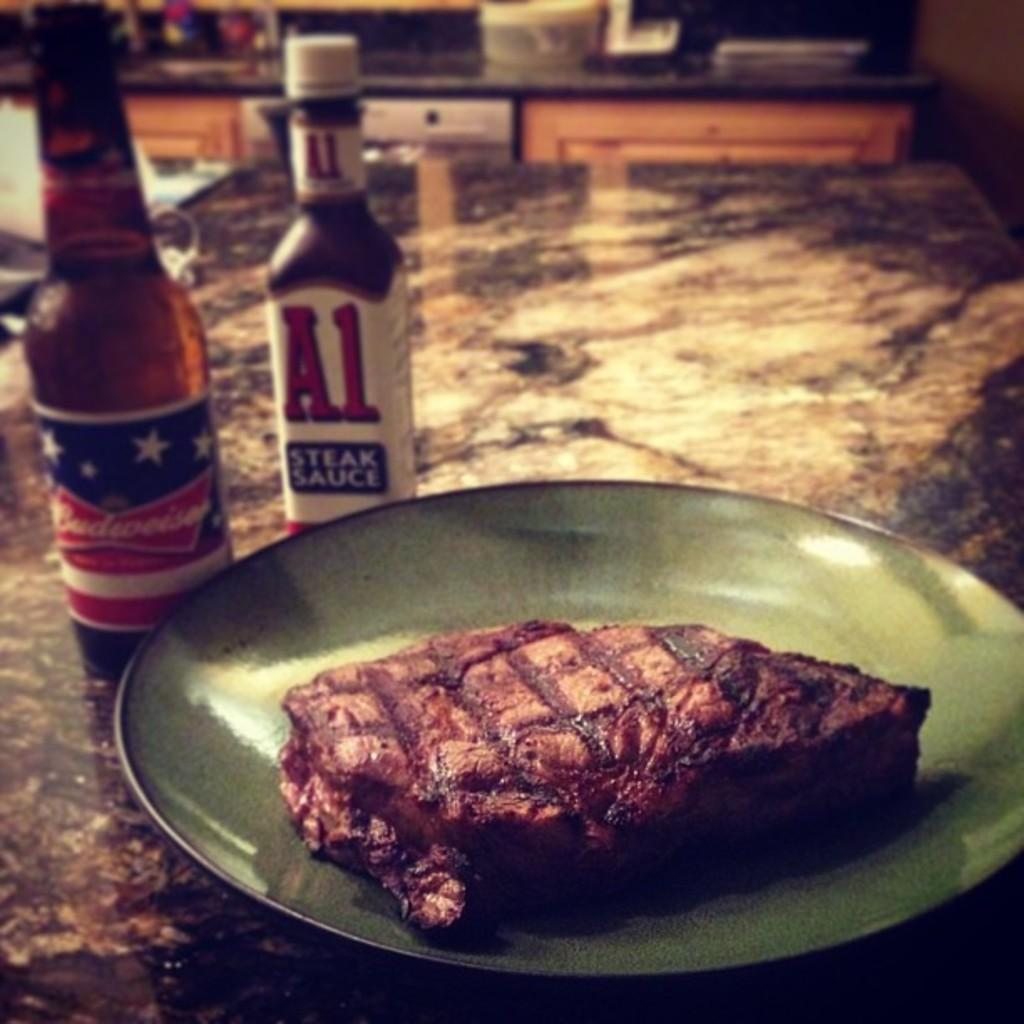<image>
Describe the image concisely. A bottle of A1 steak sauce is next to a bottle of beer. 